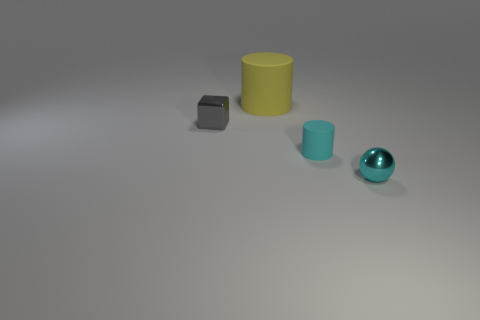What number of other objects are there of the same color as the big matte thing?
Your response must be concise. 0. Does the cylinder that is in front of the big yellow rubber cylinder have the same size as the object that is to the left of the large rubber cylinder?
Ensure brevity in your answer.  Yes. Do the gray object and the thing behind the gray shiny object have the same material?
Make the answer very short. No. Are there more big cylinders behind the metal cube than yellow matte things right of the small cyan metal thing?
Make the answer very short. Yes. What is the color of the tiny thing left of the big yellow object that is behind the tiny cyan rubber object?
Offer a terse response. Gray. How many spheres are either cyan matte things or tiny gray objects?
Give a very brief answer. 0. How many tiny shiny things are in front of the tiny gray block and behind the cyan shiny object?
Give a very brief answer. 0. There is a rubber object in front of the big yellow matte cylinder; what is its color?
Give a very brief answer. Cyan. There is a cyan cylinder that is made of the same material as the yellow object; what is its size?
Ensure brevity in your answer.  Small. There is a tiny metallic object that is on the left side of the small ball; how many small cubes are on the right side of it?
Your response must be concise. 0. 